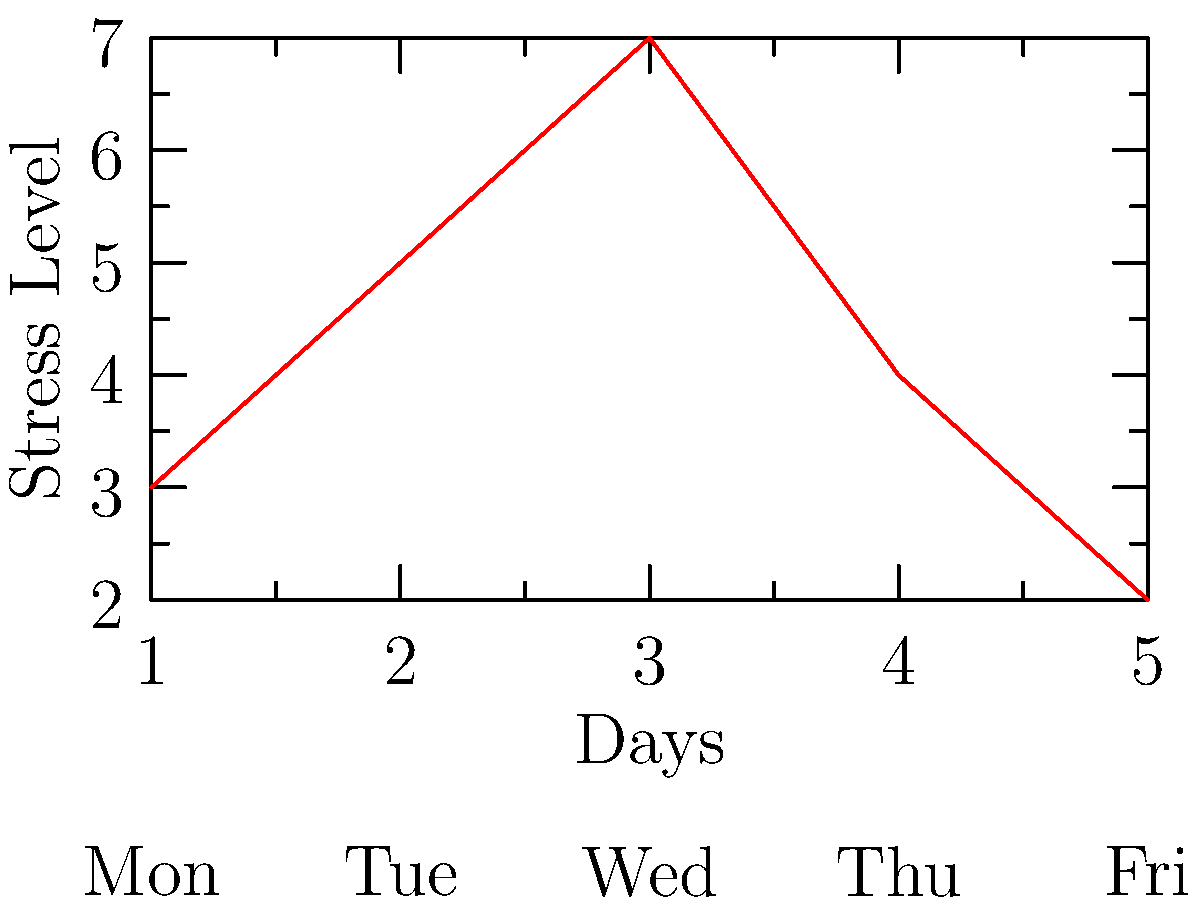Analyze the line graph depicting stress levels over a work week. On which day does the stress level peak, and how might you suggest ways to mitigate this stress for your lab colleagues? 1. Examine the graph: The x-axis represents days of the work week, and the y-axis represents stress levels.

2. Identify the peak: The highest point on the graph occurs on day 3 (Wednesday), indicating the highest stress level.

3. Consider potential causes: Midweek stress peaks are common due to workload accumulation and deadline pressures.

4. Suggest mitigation strategies:
   a) Encourage short breaks throughout the day for relaxation and refocusing.
   b) Implement a midweek team check-in to address concerns and redistribute workload if necessary.
   c) Organize a brief mindfulness or stretching session during lunch break.
   d) Promote time management techniques to prevent work buildup.
   e) Ensure clear communication about priorities and deadlines to reduce uncertainty-related stress.

5. Emphasize work-life balance: Remind colleagues to maintain healthy habits outside of work, such as exercise, proper sleep, and leisure activities.

6. Offer emotional support: Be available to listen to colleagues' concerns and provide encouragement.

7. Lead by example: Demonstrate good stress management practices in your own work routine.
Answer: Wednesday; suggest breaks, team check-ins, mindfulness sessions, time management techniques, and emotional support. 